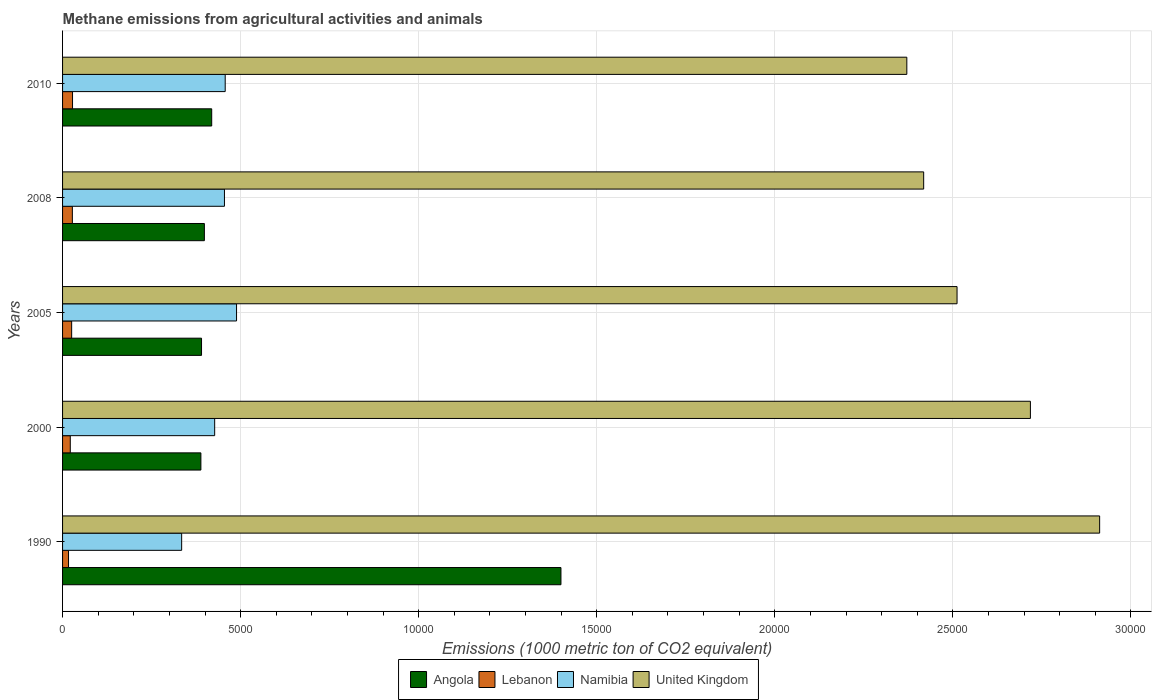How many different coloured bars are there?
Provide a short and direct response. 4. How many groups of bars are there?
Ensure brevity in your answer.  5. Are the number of bars on each tick of the Y-axis equal?
Your answer should be compact. Yes. How many bars are there on the 2nd tick from the top?
Your answer should be very brief. 4. In how many cases, is the number of bars for a given year not equal to the number of legend labels?
Offer a very short reply. 0. What is the amount of methane emitted in Namibia in 1990?
Keep it short and to the point. 3344.1. Across all years, what is the maximum amount of methane emitted in Angola?
Provide a short and direct response. 1.40e+04. Across all years, what is the minimum amount of methane emitted in United Kingdom?
Your answer should be very brief. 2.37e+04. In which year was the amount of methane emitted in Namibia maximum?
Offer a terse response. 2005. In which year was the amount of methane emitted in United Kingdom minimum?
Your answer should be compact. 2010. What is the total amount of methane emitted in Angola in the graph?
Provide a succinct answer. 3.00e+04. What is the difference between the amount of methane emitted in United Kingdom in 1990 and that in 2000?
Provide a short and direct response. 1944.1. What is the difference between the amount of methane emitted in Namibia in 1990 and the amount of methane emitted in Lebanon in 2000?
Your response must be concise. 3127.4. What is the average amount of methane emitted in Angola per year?
Your answer should be very brief. 5990.38. In the year 2000, what is the difference between the amount of methane emitted in Namibia and amount of methane emitted in United Kingdom?
Offer a very short reply. -2.29e+04. In how many years, is the amount of methane emitted in Namibia greater than 17000 1000 metric ton?
Your answer should be very brief. 0. What is the ratio of the amount of methane emitted in Namibia in 1990 to that in 2008?
Ensure brevity in your answer.  0.74. What is the difference between the highest and the second highest amount of methane emitted in Namibia?
Offer a very short reply. 318.4. What is the difference between the highest and the lowest amount of methane emitted in United Kingdom?
Provide a short and direct response. 5414.5. In how many years, is the amount of methane emitted in Namibia greater than the average amount of methane emitted in Namibia taken over all years?
Provide a short and direct response. 3. Is the sum of the amount of methane emitted in Lebanon in 2005 and 2008 greater than the maximum amount of methane emitted in Namibia across all years?
Your answer should be very brief. No. What does the 2nd bar from the bottom in 1990 represents?
Keep it short and to the point. Lebanon. Is it the case that in every year, the sum of the amount of methane emitted in United Kingdom and amount of methane emitted in Namibia is greater than the amount of methane emitted in Angola?
Your answer should be very brief. Yes. How many years are there in the graph?
Keep it short and to the point. 5. What is the difference between two consecutive major ticks on the X-axis?
Provide a short and direct response. 5000. Does the graph contain any zero values?
Give a very brief answer. No. Where does the legend appear in the graph?
Your answer should be very brief. Bottom center. How many legend labels are there?
Keep it short and to the point. 4. How are the legend labels stacked?
Provide a short and direct response. Horizontal. What is the title of the graph?
Provide a succinct answer. Methane emissions from agricultural activities and animals. Does "Panama" appear as one of the legend labels in the graph?
Offer a terse response. No. What is the label or title of the X-axis?
Your response must be concise. Emissions (1000 metric ton of CO2 equivalent). What is the Emissions (1000 metric ton of CO2 equivalent) in Angola in 1990?
Provide a succinct answer. 1.40e+04. What is the Emissions (1000 metric ton of CO2 equivalent) in Lebanon in 1990?
Keep it short and to the point. 167.6. What is the Emissions (1000 metric ton of CO2 equivalent) in Namibia in 1990?
Keep it short and to the point. 3344.1. What is the Emissions (1000 metric ton of CO2 equivalent) in United Kingdom in 1990?
Ensure brevity in your answer.  2.91e+04. What is the Emissions (1000 metric ton of CO2 equivalent) of Angola in 2000?
Keep it short and to the point. 3884.4. What is the Emissions (1000 metric ton of CO2 equivalent) in Lebanon in 2000?
Your answer should be very brief. 216.7. What is the Emissions (1000 metric ton of CO2 equivalent) of Namibia in 2000?
Keep it short and to the point. 4271.2. What is the Emissions (1000 metric ton of CO2 equivalent) in United Kingdom in 2000?
Your answer should be compact. 2.72e+04. What is the Emissions (1000 metric ton of CO2 equivalent) in Angola in 2005?
Provide a short and direct response. 3902.3. What is the Emissions (1000 metric ton of CO2 equivalent) in Lebanon in 2005?
Offer a very short reply. 255.2. What is the Emissions (1000 metric ton of CO2 equivalent) in Namibia in 2005?
Your answer should be very brief. 4885.4. What is the Emissions (1000 metric ton of CO2 equivalent) of United Kingdom in 2005?
Ensure brevity in your answer.  2.51e+04. What is the Emissions (1000 metric ton of CO2 equivalent) in Angola in 2008?
Keep it short and to the point. 3982. What is the Emissions (1000 metric ton of CO2 equivalent) in Lebanon in 2008?
Offer a terse response. 275. What is the Emissions (1000 metric ton of CO2 equivalent) of Namibia in 2008?
Keep it short and to the point. 4545.9. What is the Emissions (1000 metric ton of CO2 equivalent) of United Kingdom in 2008?
Provide a succinct answer. 2.42e+04. What is the Emissions (1000 metric ton of CO2 equivalent) in Angola in 2010?
Provide a short and direct response. 4188. What is the Emissions (1000 metric ton of CO2 equivalent) in Lebanon in 2010?
Make the answer very short. 280. What is the Emissions (1000 metric ton of CO2 equivalent) in Namibia in 2010?
Give a very brief answer. 4567. What is the Emissions (1000 metric ton of CO2 equivalent) in United Kingdom in 2010?
Make the answer very short. 2.37e+04. Across all years, what is the maximum Emissions (1000 metric ton of CO2 equivalent) in Angola?
Your response must be concise. 1.40e+04. Across all years, what is the maximum Emissions (1000 metric ton of CO2 equivalent) in Lebanon?
Provide a succinct answer. 280. Across all years, what is the maximum Emissions (1000 metric ton of CO2 equivalent) in Namibia?
Your response must be concise. 4885.4. Across all years, what is the maximum Emissions (1000 metric ton of CO2 equivalent) of United Kingdom?
Your answer should be compact. 2.91e+04. Across all years, what is the minimum Emissions (1000 metric ton of CO2 equivalent) in Angola?
Provide a short and direct response. 3884.4. Across all years, what is the minimum Emissions (1000 metric ton of CO2 equivalent) of Lebanon?
Provide a succinct answer. 167.6. Across all years, what is the minimum Emissions (1000 metric ton of CO2 equivalent) of Namibia?
Your answer should be very brief. 3344.1. Across all years, what is the minimum Emissions (1000 metric ton of CO2 equivalent) in United Kingdom?
Provide a short and direct response. 2.37e+04. What is the total Emissions (1000 metric ton of CO2 equivalent) in Angola in the graph?
Give a very brief answer. 3.00e+04. What is the total Emissions (1000 metric ton of CO2 equivalent) in Lebanon in the graph?
Make the answer very short. 1194.5. What is the total Emissions (1000 metric ton of CO2 equivalent) in Namibia in the graph?
Your response must be concise. 2.16e+04. What is the total Emissions (1000 metric ton of CO2 equivalent) of United Kingdom in the graph?
Provide a succinct answer. 1.29e+05. What is the difference between the Emissions (1000 metric ton of CO2 equivalent) in Angola in 1990 and that in 2000?
Make the answer very short. 1.01e+04. What is the difference between the Emissions (1000 metric ton of CO2 equivalent) of Lebanon in 1990 and that in 2000?
Provide a short and direct response. -49.1. What is the difference between the Emissions (1000 metric ton of CO2 equivalent) in Namibia in 1990 and that in 2000?
Ensure brevity in your answer.  -927.1. What is the difference between the Emissions (1000 metric ton of CO2 equivalent) of United Kingdom in 1990 and that in 2000?
Offer a terse response. 1944.1. What is the difference between the Emissions (1000 metric ton of CO2 equivalent) of Angola in 1990 and that in 2005?
Provide a short and direct response. 1.01e+04. What is the difference between the Emissions (1000 metric ton of CO2 equivalent) of Lebanon in 1990 and that in 2005?
Offer a very short reply. -87.6. What is the difference between the Emissions (1000 metric ton of CO2 equivalent) in Namibia in 1990 and that in 2005?
Your answer should be very brief. -1541.3. What is the difference between the Emissions (1000 metric ton of CO2 equivalent) of United Kingdom in 1990 and that in 2005?
Provide a succinct answer. 4004.1. What is the difference between the Emissions (1000 metric ton of CO2 equivalent) of Angola in 1990 and that in 2008?
Provide a succinct answer. 1.00e+04. What is the difference between the Emissions (1000 metric ton of CO2 equivalent) in Lebanon in 1990 and that in 2008?
Your response must be concise. -107.4. What is the difference between the Emissions (1000 metric ton of CO2 equivalent) in Namibia in 1990 and that in 2008?
Provide a short and direct response. -1201.8. What is the difference between the Emissions (1000 metric ton of CO2 equivalent) of United Kingdom in 1990 and that in 2008?
Offer a terse response. 4941.2. What is the difference between the Emissions (1000 metric ton of CO2 equivalent) of Angola in 1990 and that in 2010?
Your answer should be compact. 9807.2. What is the difference between the Emissions (1000 metric ton of CO2 equivalent) in Lebanon in 1990 and that in 2010?
Provide a short and direct response. -112.4. What is the difference between the Emissions (1000 metric ton of CO2 equivalent) in Namibia in 1990 and that in 2010?
Provide a succinct answer. -1222.9. What is the difference between the Emissions (1000 metric ton of CO2 equivalent) of United Kingdom in 1990 and that in 2010?
Offer a terse response. 5414.5. What is the difference between the Emissions (1000 metric ton of CO2 equivalent) in Angola in 2000 and that in 2005?
Provide a succinct answer. -17.9. What is the difference between the Emissions (1000 metric ton of CO2 equivalent) of Lebanon in 2000 and that in 2005?
Provide a short and direct response. -38.5. What is the difference between the Emissions (1000 metric ton of CO2 equivalent) of Namibia in 2000 and that in 2005?
Provide a short and direct response. -614.2. What is the difference between the Emissions (1000 metric ton of CO2 equivalent) in United Kingdom in 2000 and that in 2005?
Offer a very short reply. 2060. What is the difference between the Emissions (1000 metric ton of CO2 equivalent) of Angola in 2000 and that in 2008?
Your answer should be compact. -97.6. What is the difference between the Emissions (1000 metric ton of CO2 equivalent) in Lebanon in 2000 and that in 2008?
Give a very brief answer. -58.3. What is the difference between the Emissions (1000 metric ton of CO2 equivalent) in Namibia in 2000 and that in 2008?
Provide a succinct answer. -274.7. What is the difference between the Emissions (1000 metric ton of CO2 equivalent) of United Kingdom in 2000 and that in 2008?
Your answer should be very brief. 2997.1. What is the difference between the Emissions (1000 metric ton of CO2 equivalent) of Angola in 2000 and that in 2010?
Provide a short and direct response. -303.6. What is the difference between the Emissions (1000 metric ton of CO2 equivalent) in Lebanon in 2000 and that in 2010?
Your answer should be compact. -63.3. What is the difference between the Emissions (1000 metric ton of CO2 equivalent) in Namibia in 2000 and that in 2010?
Your answer should be compact. -295.8. What is the difference between the Emissions (1000 metric ton of CO2 equivalent) of United Kingdom in 2000 and that in 2010?
Ensure brevity in your answer.  3470.4. What is the difference between the Emissions (1000 metric ton of CO2 equivalent) of Angola in 2005 and that in 2008?
Your answer should be compact. -79.7. What is the difference between the Emissions (1000 metric ton of CO2 equivalent) of Lebanon in 2005 and that in 2008?
Give a very brief answer. -19.8. What is the difference between the Emissions (1000 metric ton of CO2 equivalent) in Namibia in 2005 and that in 2008?
Keep it short and to the point. 339.5. What is the difference between the Emissions (1000 metric ton of CO2 equivalent) in United Kingdom in 2005 and that in 2008?
Provide a short and direct response. 937.1. What is the difference between the Emissions (1000 metric ton of CO2 equivalent) in Angola in 2005 and that in 2010?
Provide a short and direct response. -285.7. What is the difference between the Emissions (1000 metric ton of CO2 equivalent) of Lebanon in 2005 and that in 2010?
Make the answer very short. -24.8. What is the difference between the Emissions (1000 metric ton of CO2 equivalent) in Namibia in 2005 and that in 2010?
Ensure brevity in your answer.  318.4. What is the difference between the Emissions (1000 metric ton of CO2 equivalent) of United Kingdom in 2005 and that in 2010?
Make the answer very short. 1410.4. What is the difference between the Emissions (1000 metric ton of CO2 equivalent) of Angola in 2008 and that in 2010?
Ensure brevity in your answer.  -206. What is the difference between the Emissions (1000 metric ton of CO2 equivalent) in Namibia in 2008 and that in 2010?
Keep it short and to the point. -21.1. What is the difference between the Emissions (1000 metric ton of CO2 equivalent) in United Kingdom in 2008 and that in 2010?
Provide a short and direct response. 473.3. What is the difference between the Emissions (1000 metric ton of CO2 equivalent) in Angola in 1990 and the Emissions (1000 metric ton of CO2 equivalent) in Lebanon in 2000?
Your answer should be very brief. 1.38e+04. What is the difference between the Emissions (1000 metric ton of CO2 equivalent) in Angola in 1990 and the Emissions (1000 metric ton of CO2 equivalent) in Namibia in 2000?
Your response must be concise. 9724. What is the difference between the Emissions (1000 metric ton of CO2 equivalent) in Angola in 1990 and the Emissions (1000 metric ton of CO2 equivalent) in United Kingdom in 2000?
Keep it short and to the point. -1.32e+04. What is the difference between the Emissions (1000 metric ton of CO2 equivalent) of Lebanon in 1990 and the Emissions (1000 metric ton of CO2 equivalent) of Namibia in 2000?
Give a very brief answer. -4103.6. What is the difference between the Emissions (1000 metric ton of CO2 equivalent) of Lebanon in 1990 and the Emissions (1000 metric ton of CO2 equivalent) of United Kingdom in 2000?
Your answer should be compact. -2.70e+04. What is the difference between the Emissions (1000 metric ton of CO2 equivalent) in Namibia in 1990 and the Emissions (1000 metric ton of CO2 equivalent) in United Kingdom in 2000?
Ensure brevity in your answer.  -2.38e+04. What is the difference between the Emissions (1000 metric ton of CO2 equivalent) in Angola in 1990 and the Emissions (1000 metric ton of CO2 equivalent) in Lebanon in 2005?
Offer a terse response. 1.37e+04. What is the difference between the Emissions (1000 metric ton of CO2 equivalent) in Angola in 1990 and the Emissions (1000 metric ton of CO2 equivalent) in Namibia in 2005?
Keep it short and to the point. 9109.8. What is the difference between the Emissions (1000 metric ton of CO2 equivalent) of Angola in 1990 and the Emissions (1000 metric ton of CO2 equivalent) of United Kingdom in 2005?
Keep it short and to the point. -1.11e+04. What is the difference between the Emissions (1000 metric ton of CO2 equivalent) of Lebanon in 1990 and the Emissions (1000 metric ton of CO2 equivalent) of Namibia in 2005?
Offer a very short reply. -4717.8. What is the difference between the Emissions (1000 metric ton of CO2 equivalent) in Lebanon in 1990 and the Emissions (1000 metric ton of CO2 equivalent) in United Kingdom in 2005?
Offer a very short reply. -2.50e+04. What is the difference between the Emissions (1000 metric ton of CO2 equivalent) in Namibia in 1990 and the Emissions (1000 metric ton of CO2 equivalent) in United Kingdom in 2005?
Offer a terse response. -2.18e+04. What is the difference between the Emissions (1000 metric ton of CO2 equivalent) of Angola in 1990 and the Emissions (1000 metric ton of CO2 equivalent) of Lebanon in 2008?
Your answer should be very brief. 1.37e+04. What is the difference between the Emissions (1000 metric ton of CO2 equivalent) in Angola in 1990 and the Emissions (1000 metric ton of CO2 equivalent) in Namibia in 2008?
Keep it short and to the point. 9449.3. What is the difference between the Emissions (1000 metric ton of CO2 equivalent) of Angola in 1990 and the Emissions (1000 metric ton of CO2 equivalent) of United Kingdom in 2008?
Offer a very short reply. -1.02e+04. What is the difference between the Emissions (1000 metric ton of CO2 equivalent) of Lebanon in 1990 and the Emissions (1000 metric ton of CO2 equivalent) of Namibia in 2008?
Give a very brief answer. -4378.3. What is the difference between the Emissions (1000 metric ton of CO2 equivalent) in Lebanon in 1990 and the Emissions (1000 metric ton of CO2 equivalent) in United Kingdom in 2008?
Your answer should be very brief. -2.40e+04. What is the difference between the Emissions (1000 metric ton of CO2 equivalent) in Namibia in 1990 and the Emissions (1000 metric ton of CO2 equivalent) in United Kingdom in 2008?
Offer a very short reply. -2.08e+04. What is the difference between the Emissions (1000 metric ton of CO2 equivalent) in Angola in 1990 and the Emissions (1000 metric ton of CO2 equivalent) in Lebanon in 2010?
Give a very brief answer. 1.37e+04. What is the difference between the Emissions (1000 metric ton of CO2 equivalent) of Angola in 1990 and the Emissions (1000 metric ton of CO2 equivalent) of Namibia in 2010?
Ensure brevity in your answer.  9428.2. What is the difference between the Emissions (1000 metric ton of CO2 equivalent) in Angola in 1990 and the Emissions (1000 metric ton of CO2 equivalent) in United Kingdom in 2010?
Your answer should be compact. -9712.6. What is the difference between the Emissions (1000 metric ton of CO2 equivalent) of Lebanon in 1990 and the Emissions (1000 metric ton of CO2 equivalent) of Namibia in 2010?
Offer a very short reply. -4399.4. What is the difference between the Emissions (1000 metric ton of CO2 equivalent) in Lebanon in 1990 and the Emissions (1000 metric ton of CO2 equivalent) in United Kingdom in 2010?
Your answer should be compact. -2.35e+04. What is the difference between the Emissions (1000 metric ton of CO2 equivalent) of Namibia in 1990 and the Emissions (1000 metric ton of CO2 equivalent) of United Kingdom in 2010?
Give a very brief answer. -2.04e+04. What is the difference between the Emissions (1000 metric ton of CO2 equivalent) in Angola in 2000 and the Emissions (1000 metric ton of CO2 equivalent) in Lebanon in 2005?
Your response must be concise. 3629.2. What is the difference between the Emissions (1000 metric ton of CO2 equivalent) in Angola in 2000 and the Emissions (1000 metric ton of CO2 equivalent) in Namibia in 2005?
Make the answer very short. -1001. What is the difference between the Emissions (1000 metric ton of CO2 equivalent) of Angola in 2000 and the Emissions (1000 metric ton of CO2 equivalent) of United Kingdom in 2005?
Keep it short and to the point. -2.12e+04. What is the difference between the Emissions (1000 metric ton of CO2 equivalent) of Lebanon in 2000 and the Emissions (1000 metric ton of CO2 equivalent) of Namibia in 2005?
Offer a very short reply. -4668.7. What is the difference between the Emissions (1000 metric ton of CO2 equivalent) of Lebanon in 2000 and the Emissions (1000 metric ton of CO2 equivalent) of United Kingdom in 2005?
Provide a succinct answer. -2.49e+04. What is the difference between the Emissions (1000 metric ton of CO2 equivalent) of Namibia in 2000 and the Emissions (1000 metric ton of CO2 equivalent) of United Kingdom in 2005?
Your answer should be very brief. -2.08e+04. What is the difference between the Emissions (1000 metric ton of CO2 equivalent) in Angola in 2000 and the Emissions (1000 metric ton of CO2 equivalent) in Lebanon in 2008?
Keep it short and to the point. 3609.4. What is the difference between the Emissions (1000 metric ton of CO2 equivalent) in Angola in 2000 and the Emissions (1000 metric ton of CO2 equivalent) in Namibia in 2008?
Offer a terse response. -661.5. What is the difference between the Emissions (1000 metric ton of CO2 equivalent) of Angola in 2000 and the Emissions (1000 metric ton of CO2 equivalent) of United Kingdom in 2008?
Give a very brief answer. -2.03e+04. What is the difference between the Emissions (1000 metric ton of CO2 equivalent) of Lebanon in 2000 and the Emissions (1000 metric ton of CO2 equivalent) of Namibia in 2008?
Give a very brief answer. -4329.2. What is the difference between the Emissions (1000 metric ton of CO2 equivalent) of Lebanon in 2000 and the Emissions (1000 metric ton of CO2 equivalent) of United Kingdom in 2008?
Ensure brevity in your answer.  -2.40e+04. What is the difference between the Emissions (1000 metric ton of CO2 equivalent) in Namibia in 2000 and the Emissions (1000 metric ton of CO2 equivalent) in United Kingdom in 2008?
Provide a succinct answer. -1.99e+04. What is the difference between the Emissions (1000 metric ton of CO2 equivalent) of Angola in 2000 and the Emissions (1000 metric ton of CO2 equivalent) of Lebanon in 2010?
Make the answer very short. 3604.4. What is the difference between the Emissions (1000 metric ton of CO2 equivalent) in Angola in 2000 and the Emissions (1000 metric ton of CO2 equivalent) in Namibia in 2010?
Ensure brevity in your answer.  -682.6. What is the difference between the Emissions (1000 metric ton of CO2 equivalent) of Angola in 2000 and the Emissions (1000 metric ton of CO2 equivalent) of United Kingdom in 2010?
Your response must be concise. -1.98e+04. What is the difference between the Emissions (1000 metric ton of CO2 equivalent) of Lebanon in 2000 and the Emissions (1000 metric ton of CO2 equivalent) of Namibia in 2010?
Give a very brief answer. -4350.3. What is the difference between the Emissions (1000 metric ton of CO2 equivalent) in Lebanon in 2000 and the Emissions (1000 metric ton of CO2 equivalent) in United Kingdom in 2010?
Your answer should be compact. -2.35e+04. What is the difference between the Emissions (1000 metric ton of CO2 equivalent) in Namibia in 2000 and the Emissions (1000 metric ton of CO2 equivalent) in United Kingdom in 2010?
Your response must be concise. -1.94e+04. What is the difference between the Emissions (1000 metric ton of CO2 equivalent) in Angola in 2005 and the Emissions (1000 metric ton of CO2 equivalent) in Lebanon in 2008?
Keep it short and to the point. 3627.3. What is the difference between the Emissions (1000 metric ton of CO2 equivalent) in Angola in 2005 and the Emissions (1000 metric ton of CO2 equivalent) in Namibia in 2008?
Offer a very short reply. -643.6. What is the difference between the Emissions (1000 metric ton of CO2 equivalent) of Angola in 2005 and the Emissions (1000 metric ton of CO2 equivalent) of United Kingdom in 2008?
Give a very brief answer. -2.03e+04. What is the difference between the Emissions (1000 metric ton of CO2 equivalent) in Lebanon in 2005 and the Emissions (1000 metric ton of CO2 equivalent) in Namibia in 2008?
Offer a terse response. -4290.7. What is the difference between the Emissions (1000 metric ton of CO2 equivalent) of Lebanon in 2005 and the Emissions (1000 metric ton of CO2 equivalent) of United Kingdom in 2008?
Your response must be concise. -2.39e+04. What is the difference between the Emissions (1000 metric ton of CO2 equivalent) in Namibia in 2005 and the Emissions (1000 metric ton of CO2 equivalent) in United Kingdom in 2008?
Your answer should be very brief. -1.93e+04. What is the difference between the Emissions (1000 metric ton of CO2 equivalent) in Angola in 2005 and the Emissions (1000 metric ton of CO2 equivalent) in Lebanon in 2010?
Make the answer very short. 3622.3. What is the difference between the Emissions (1000 metric ton of CO2 equivalent) in Angola in 2005 and the Emissions (1000 metric ton of CO2 equivalent) in Namibia in 2010?
Ensure brevity in your answer.  -664.7. What is the difference between the Emissions (1000 metric ton of CO2 equivalent) of Angola in 2005 and the Emissions (1000 metric ton of CO2 equivalent) of United Kingdom in 2010?
Keep it short and to the point. -1.98e+04. What is the difference between the Emissions (1000 metric ton of CO2 equivalent) of Lebanon in 2005 and the Emissions (1000 metric ton of CO2 equivalent) of Namibia in 2010?
Keep it short and to the point. -4311.8. What is the difference between the Emissions (1000 metric ton of CO2 equivalent) in Lebanon in 2005 and the Emissions (1000 metric ton of CO2 equivalent) in United Kingdom in 2010?
Offer a terse response. -2.35e+04. What is the difference between the Emissions (1000 metric ton of CO2 equivalent) in Namibia in 2005 and the Emissions (1000 metric ton of CO2 equivalent) in United Kingdom in 2010?
Offer a very short reply. -1.88e+04. What is the difference between the Emissions (1000 metric ton of CO2 equivalent) of Angola in 2008 and the Emissions (1000 metric ton of CO2 equivalent) of Lebanon in 2010?
Give a very brief answer. 3702. What is the difference between the Emissions (1000 metric ton of CO2 equivalent) in Angola in 2008 and the Emissions (1000 metric ton of CO2 equivalent) in Namibia in 2010?
Provide a succinct answer. -585. What is the difference between the Emissions (1000 metric ton of CO2 equivalent) in Angola in 2008 and the Emissions (1000 metric ton of CO2 equivalent) in United Kingdom in 2010?
Your response must be concise. -1.97e+04. What is the difference between the Emissions (1000 metric ton of CO2 equivalent) of Lebanon in 2008 and the Emissions (1000 metric ton of CO2 equivalent) of Namibia in 2010?
Provide a succinct answer. -4292. What is the difference between the Emissions (1000 metric ton of CO2 equivalent) in Lebanon in 2008 and the Emissions (1000 metric ton of CO2 equivalent) in United Kingdom in 2010?
Your answer should be compact. -2.34e+04. What is the difference between the Emissions (1000 metric ton of CO2 equivalent) in Namibia in 2008 and the Emissions (1000 metric ton of CO2 equivalent) in United Kingdom in 2010?
Ensure brevity in your answer.  -1.92e+04. What is the average Emissions (1000 metric ton of CO2 equivalent) of Angola per year?
Make the answer very short. 5990.38. What is the average Emissions (1000 metric ton of CO2 equivalent) of Lebanon per year?
Keep it short and to the point. 238.9. What is the average Emissions (1000 metric ton of CO2 equivalent) of Namibia per year?
Offer a terse response. 4322.72. What is the average Emissions (1000 metric ton of CO2 equivalent) in United Kingdom per year?
Give a very brief answer. 2.59e+04. In the year 1990, what is the difference between the Emissions (1000 metric ton of CO2 equivalent) in Angola and Emissions (1000 metric ton of CO2 equivalent) in Lebanon?
Provide a succinct answer. 1.38e+04. In the year 1990, what is the difference between the Emissions (1000 metric ton of CO2 equivalent) of Angola and Emissions (1000 metric ton of CO2 equivalent) of Namibia?
Make the answer very short. 1.07e+04. In the year 1990, what is the difference between the Emissions (1000 metric ton of CO2 equivalent) in Angola and Emissions (1000 metric ton of CO2 equivalent) in United Kingdom?
Your answer should be very brief. -1.51e+04. In the year 1990, what is the difference between the Emissions (1000 metric ton of CO2 equivalent) of Lebanon and Emissions (1000 metric ton of CO2 equivalent) of Namibia?
Your answer should be very brief. -3176.5. In the year 1990, what is the difference between the Emissions (1000 metric ton of CO2 equivalent) in Lebanon and Emissions (1000 metric ton of CO2 equivalent) in United Kingdom?
Your answer should be compact. -2.90e+04. In the year 1990, what is the difference between the Emissions (1000 metric ton of CO2 equivalent) of Namibia and Emissions (1000 metric ton of CO2 equivalent) of United Kingdom?
Your response must be concise. -2.58e+04. In the year 2000, what is the difference between the Emissions (1000 metric ton of CO2 equivalent) of Angola and Emissions (1000 metric ton of CO2 equivalent) of Lebanon?
Make the answer very short. 3667.7. In the year 2000, what is the difference between the Emissions (1000 metric ton of CO2 equivalent) of Angola and Emissions (1000 metric ton of CO2 equivalent) of Namibia?
Provide a short and direct response. -386.8. In the year 2000, what is the difference between the Emissions (1000 metric ton of CO2 equivalent) in Angola and Emissions (1000 metric ton of CO2 equivalent) in United Kingdom?
Your answer should be compact. -2.33e+04. In the year 2000, what is the difference between the Emissions (1000 metric ton of CO2 equivalent) in Lebanon and Emissions (1000 metric ton of CO2 equivalent) in Namibia?
Provide a succinct answer. -4054.5. In the year 2000, what is the difference between the Emissions (1000 metric ton of CO2 equivalent) of Lebanon and Emissions (1000 metric ton of CO2 equivalent) of United Kingdom?
Provide a short and direct response. -2.70e+04. In the year 2000, what is the difference between the Emissions (1000 metric ton of CO2 equivalent) in Namibia and Emissions (1000 metric ton of CO2 equivalent) in United Kingdom?
Your response must be concise. -2.29e+04. In the year 2005, what is the difference between the Emissions (1000 metric ton of CO2 equivalent) in Angola and Emissions (1000 metric ton of CO2 equivalent) in Lebanon?
Make the answer very short. 3647.1. In the year 2005, what is the difference between the Emissions (1000 metric ton of CO2 equivalent) of Angola and Emissions (1000 metric ton of CO2 equivalent) of Namibia?
Your answer should be compact. -983.1. In the year 2005, what is the difference between the Emissions (1000 metric ton of CO2 equivalent) in Angola and Emissions (1000 metric ton of CO2 equivalent) in United Kingdom?
Provide a short and direct response. -2.12e+04. In the year 2005, what is the difference between the Emissions (1000 metric ton of CO2 equivalent) in Lebanon and Emissions (1000 metric ton of CO2 equivalent) in Namibia?
Ensure brevity in your answer.  -4630.2. In the year 2005, what is the difference between the Emissions (1000 metric ton of CO2 equivalent) in Lebanon and Emissions (1000 metric ton of CO2 equivalent) in United Kingdom?
Your answer should be very brief. -2.49e+04. In the year 2005, what is the difference between the Emissions (1000 metric ton of CO2 equivalent) in Namibia and Emissions (1000 metric ton of CO2 equivalent) in United Kingdom?
Provide a succinct answer. -2.02e+04. In the year 2008, what is the difference between the Emissions (1000 metric ton of CO2 equivalent) in Angola and Emissions (1000 metric ton of CO2 equivalent) in Lebanon?
Make the answer very short. 3707. In the year 2008, what is the difference between the Emissions (1000 metric ton of CO2 equivalent) in Angola and Emissions (1000 metric ton of CO2 equivalent) in Namibia?
Make the answer very short. -563.9. In the year 2008, what is the difference between the Emissions (1000 metric ton of CO2 equivalent) in Angola and Emissions (1000 metric ton of CO2 equivalent) in United Kingdom?
Give a very brief answer. -2.02e+04. In the year 2008, what is the difference between the Emissions (1000 metric ton of CO2 equivalent) of Lebanon and Emissions (1000 metric ton of CO2 equivalent) of Namibia?
Provide a succinct answer. -4270.9. In the year 2008, what is the difference between the Emissions (1000 metric ton of CO2 equivalent) of Lebanon and Emissions (1000 metric ton of CO2 equivalent) of United Kingdom?
Ensure brevity in your answer.  -2.39e+04. In the year 2008, what is the difference between the Emissions (1000 metric ton of CO2 equivalent) in Namibia and Emissions (1000 metric ton of CO2 equivalent) in United Kingdom?
Offer a terse response. -1.96e+04. In the year 2010, what is the difference between the Emissions (1000 metric ton of CO2 equivalent) in Angola and Emissions (1000 metric ton of CO2 equivalent) in Lebanon?
Ensure brevity in your answer.  3908. In the year 2010, what is the difference between the Emissions (1000 metric ton of CO2 equivalent) of Angola and Emissions (1000 metric ton of CO2 equivalent) of Namibia?
Your answer should be very brief. -379. In the year 2010, what is the difference between the Emissions (1000 metric ton of CO2 equivalent) of Angola and Emissions (1000 metric ton of CO2 equivalent) of United Kingdom?
Give a very brief answer. -1.95e+04. In the year 2010, what is the difference between the Emissions (1000 metric ton of CO2 equivalent) in Lebanon and Emissions (1000 metric ton of CO2 equivalent) in Namibia?
Your response must be concise. -4287. In the year 2010, what is the difference between the Emissions (1000 metric ton of CO2 equivalent) of Lebanon and Emissions (1000 metric ton of CO2 equivalent) of United Kingdom?
Ensure brevity in your answer.  -2.34e+04. In the year 2010, what is the difference between the Emissions (1000 metric ton of CO2 equivalent) of Namibia and Emissions (1000 metric ton of CO2 equivalent) of United Kingdom?
Ensure brevity in your answer.  -1.91e+04. What is the ratio of the Emissions (1000 metric ton of CO2 equivalent) in Angola in 1990 to that in 2000?
Give a very brief answer. 3.6. What is the ratio of the Emissions (1000 metric ton of CO2 equivalent) of Lebanon in 1990 to that in 2000?
Provide a short and direct response. 0.77. What is the ratio of the Emissions (1000 metric ton of CO2 equivalent) of Namibia in 1990 to that in 2000?
Provide a succinct answer. 0.78. What is the ratio of the Emissions (1000 metric ton of CO2 equivalent) of United Kingdom in 1990 to that in 2000?
Ensure brevity in your answer.  1.07. What is the ratio of the Emissions (1000 metric ton of CO2 equivalent) in Angola in 1990 to that in 2005?
Keep it short and to the point. 3.59. What is the ratio of the Emissions (1000 metric ton of CO2 equivalent) of Lebanon in 1990 to that in 2005?
Your response must be concise. 0.66. What is the ratio of the Emissions (1000 metric ton of CO2 equivalent) of Namibia in 1990 to that in 2005?
Ensure brevity in your answer.  0.68. What is the ratio of the Emissions (1000 metric ton of CO2 equivalent) in United Kingdom in 1990 to that in 2005?
Your answer should be very brief. 1.16. What is the ratio of the Emissions (1000 metric ton of CO2 equivalent) in Angola in 1990 to that in 2008?
Your answer should be very brief. 3.51. What is the ratio of the Emissions (1000 metric ton of CO2 equivalent) of Lebanon in 1990 to that in 2008?
Ensure brevity in your answer.  0.61. What is the ratio of the Emissions (1000 metric ton of CO2 equivalent) of Namibia in 1990 to that in 2008?
Your answer should be compact. 0.74. What is the ratio of the Emissions (1000 metric ton of CO2 equivalent) in United Kingdom in 1990 to that in 2008?
Your answer should be compact. 1.2. What is the ratio of the Emissions (1000 metric ton of CO2 equivalent) of Angola in 1990 to that in 2010?
Give a very brief answer. 3.34. What is the ratio of the Emissions (1000 metric ton of CO2 equivalent) in Lebanon in 1990 to that in 2010?
Make the answer very short. 0.6. What is the ratio of the Emissions (1000 metric ton of CO2 equivalent) of Namibia in 1990 to that in 2010?
Your response must be concise. 0.73. What is the ratio of the Emissions (1000 metric ton of CO2 equivalent) of United Kingdom in 1990 to that in 2010?
Your response must be concise. 1.23. What is the ratio of the Emissions (1000 metric ton of CO2 equivalent) of Lebanon in 2000 to that in 2005?
Your answer should be very brief. 0.85. What is the ratio of the Emissions (1000 metric ton of CO2 equivalent) of Namibia in 2000 to that in 2005?
Keep it short and to the point. 0.87. What is the ratio of the Emissions (1000 metric ton of CO2 equivalent) in United Kingdom in 2000 to that in 2005?
Your response must be concise. 1.08. What is the ratio of the Emissions (1000 metric ton of CO2 equivalent) in Angola in 2000 to that in 2008?
Your answer should be compact. 0.98. What is the ratio of the Emissions (1000 metric ton of CO2 equivalent) of Lebanon in 2000 to that in 2008?
Your response must be concise. 0.79. What is the ratio of the Emissions (1000 metric ton of CO2 equivalent) in Namibia in 2000 to that in 2008?
Provide a short and direct response. 0.94. What is the ratio of the Emissions (1000 metric ton of CO2 equivalent) of United Kingdom in 2000 to that in 2008?
Your response must be concise. 1.12. What is the ratio of the Emissions (1000 metric ton of CO2 equivalent) of Angola in 2000 to that in 2010?
Your answer should be very brief. 0.93. What is the ratio of the Emissions (1000 metric ton of CO2 equivalent) of Lebanon in 2000 to that in 2010?
Provide a short and direct response. 0.77. What is the ratio of the Emissions (1000 metric ton of CO2 equivalent) in Namibia in 2000 to that in 2010?
Your response must be concise. 0.94. What is the ratio of the Emissions (1000 metric ton of CO2 equivalent) of United Kingdom in 2000 to that in 2010?
Provide a short and direct response. 1.15. What is the ratio of the Emissions (1000 metric ton of CO2 equivalent) in Lebanon in 2005 to that in 2008?
Give a very brief answer. 0.93. What is the ratio of the Emissions (1000 metric ton of CO2 equivalent) in Namibia in 2005 to that in 2008?
Offer a terse response. 1.07. What is the ratio of the Emissions (1000 metric ton of CO2 equivalent) in United Kingdom in 2005 to that in 2008?
Ensure brevity in your answer.  1.04. What is the ratio of the Emissions (1000 metric ton of CO2 equivalent) in Angola in 2005 to that in 2010?
Offer a terse response. 0.93. What is the ratio of the Emissions (1000 metric ton of CO2 equivalent) in Lebanon in 2005 to that in 2010?
Offer a very short reply. 0.91. What is the ratio of the Emissions (1000 metric ton of CO2 equivalent) of Namibia in 2005 to that in 2010?
Provide a succinct answer. 1.07. What is the ratio of the Emissions (1000 metric ton of CO2 equivalent) of United Kingdom in 2005 to that in 2010?
Offer a terse response. 1.06. What is the ratio of the Emissions (1000 metric ton of CO2 equivalent) of Angola in 2008 to that in 2010?
Ensure brevity in your answer.  0.95. What is the ratio of the Emissions (1000 metric ton of CO2 equivalent) of Lebanon in 2008 to that in 2010?
Provide a short and direct response. 0.98. What is the difference between the highest and the second highest Emissions (1000 metric ton of CO2 equivalent) in Angola?
Your response must be concise. 9807.2. What is the difference between the highest and the second highest Emissions (1000 metric ton of CO2 equivalent) in Lebanon?
Keep it short and to the point. 5. What is the difference between the highest and the second highest Emissions (1000 metric ton of CO2 equivalent) of Namibia?
Provide a short and direct response. 318.4. What is the difference between the highest and the second highest Emissions (1000 metric ton of CO2 equivalent) in United Kingdom?
Provide a short and direct response. 1944.1. What is the difference between the highest and the lowest Emissions (1000 metric ton of CO2 equivalent) of Angola?
Offer a terse response. 1.01e+04. What is the difference between the highest and the lowest Emissions (1000 metric ton of CO2 equivalent) of Lebanon?
Your response must be concise. 112.4. What is the difference between the highest and the lowest Emissions (1000 metric ton of CO2 equivalent) in Namibia?
Your answer should be compact. 1541.3. What is the difference between the highest and the lowest Emissions (1000 metric ton of CO2 equivalent) in United Kingdom?
Offer a very short reply. 5414.5. 